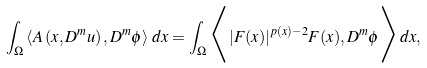Convert formula to latex. <formula><loc_0><loc_0><loc_500><loc_500>\int _ { \Omega } \left < A \left ( x , D ^ { m } u \right ) , D ^ { m } \phi \right > \, d x = \int _ { \Omega } \Big < | F ( x ) | ^ { p ( x ) - 2 } F ( x ) , D ^ { m } \phi \Big > \, d x ,</formula> 